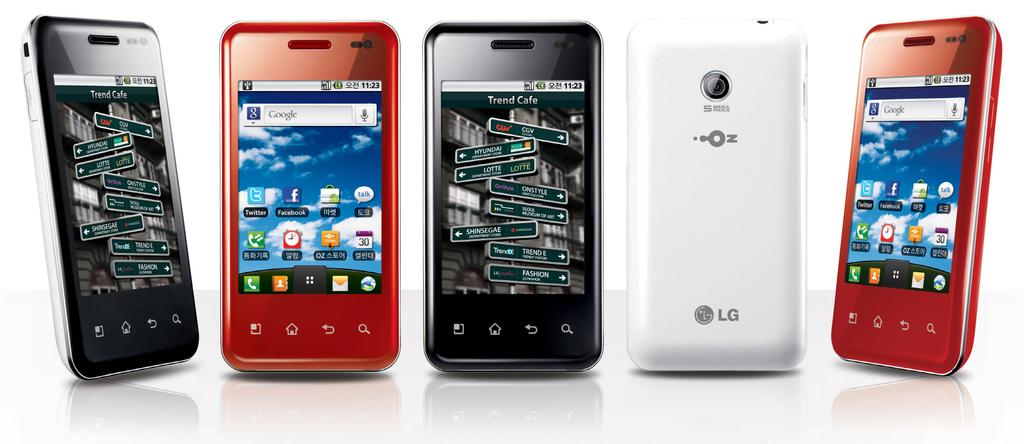<image>
Create a compact narrative representing the image presented. A number of LG smart phones in different colors against a white back drop. 